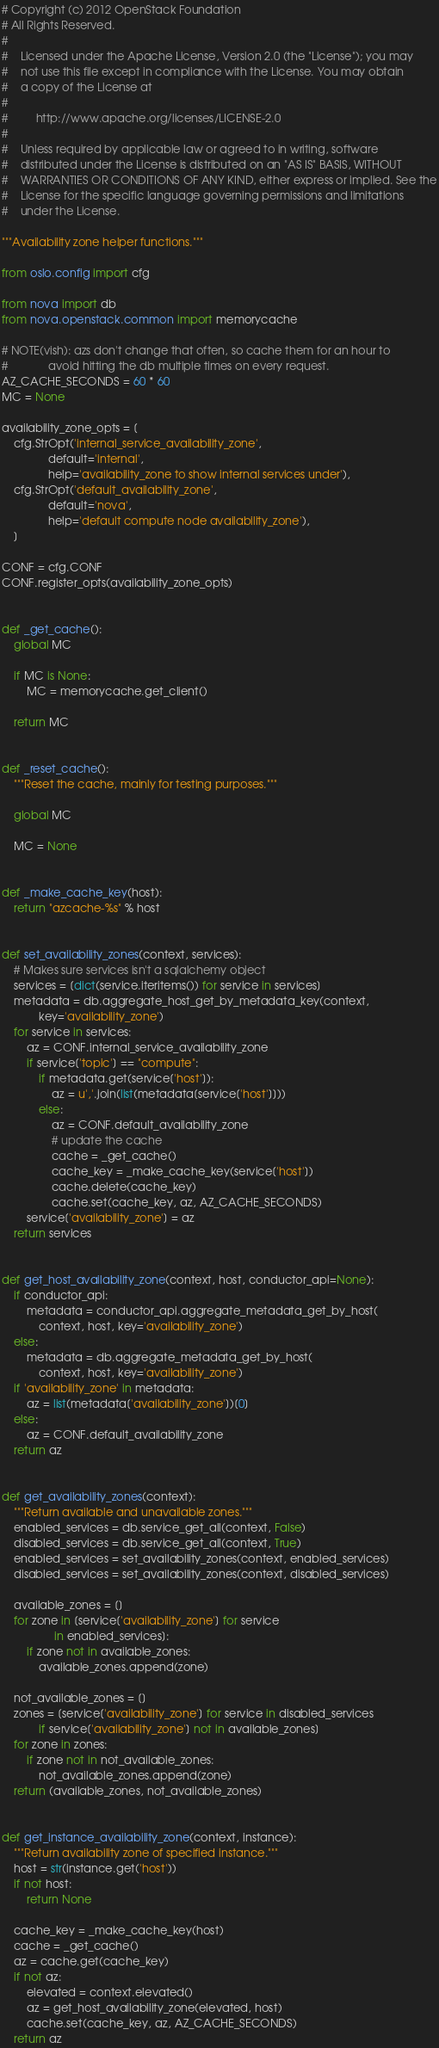Convert code to text. <code><loc_0><loc_0><loc_500><loc_500><_Python_># Copyright (c) 2012 OpenStack Foundation
# All Rights Reserved.
#
#    Licensed under the Apache License, Version 2.0 (the "License"); you may
#    not use this file except in compliance with the License. You may obtain
#    a copy of the License at
#
#         http://www.apache.org/licenses/LICENSE-2.0
#
#    Unless required by applicable law or agreed to in writing, software
#    distributed under the License is distributed on an "AS IS" BASIS, WITHOUT
#    WARRANTIES OR CONDITIONS OF ANY KIND, either express or implied. See the
#    License for the specific language governing permissions and limitations
#    under the License.

"""Availability zone helper functions."""

from oslo.config import cfg

from nova import db
from nova.openstack.common import memorycache

# NOTE(vish): azs don't change that often, so cache them for an hour to
#             avoid hitting the db multiple times on every request.
AZ_CACHE_SECONDS = 60 * 60
MC = None

availability_zone_opts = [
    cfg.StrOpt('internal_service_availability_zone',
               default='internal',
               help='availability_zone to show internal services under'),
    cfg.StrOpt('default_availability_zone',
               default='nova',
               help='default compute node availability_zone'),
    ]

CONF = cfg.CONF
CONF.register_opts(availability_zone_opts)


def _get_cache():
    global MC

    if MC is None:
        MC = memorycache.get_client()

    return MC


def _reset_cache():
    """Reset the cache, mainly for testing purposes."""

    global MC

    MC = None


def _make_cache_key(host):
    return "azcache-%s" % host


def set_availability_zones(context, services):
    # Makes sure services isn't a sqlalchemy object
    services = [dict(service.iteritems()) for service in services]
    metadata = db.aggregate_host_get_by_metadata_key(context,
            key='availability_zone')
    for service in services:
        az = CONF.internal_service_availability_zone
        if service['topic'] == "compute":
            if metadata.get(service['host']):
                az = u','.join(list(metadata[service['host']]))
            else:
                az = CONF.default_availability_zone
                # update the cache
                cache = _get_cache()
                cache_key = _make_cache_key(service['host'])
                cache.delete(cache_key)
                cache.set(cache_key, az, AZ_CACHE_SECONDS)
        service['availability_zone'] = az
    return services


def get_host_availability_zone(context, host, conductor_api=None):
    if conductor_api:
        metadata = conductor_api.aggregate_metadata_get_by_host(
            context, host, key='availability_zone')
    else:
        metadata = db.aggregate_metadata_get_by_host(
            context, host, key='availability_zone')
    if 'availability_zone' in metadata:
        az = list(metadata['availability_zone'])[0]
    else:
        az = CONF.default_availability_zone
    return az


def get_availability_zones(context):
    """Return available and unavailable zones."""
    enabled_services = db.service_get_all(context, False)
    disabled_services = db.service_get_all(context, True)
    enabled_services = set_availability_zones(context, enabled_services)
    disabled_services = set_availability_zones(context, disabled_services)

    available_zones = []
    for zone in [service['availability_zone'] for service
                 in enabled_services]:
        if zone not in available_zones:
            available_zones.append(zone)

    not_available_zones = []
    zones = [service['availability_zone'] for service in disabled_services
            if service['availability_zone'] not in available_zones]
    for zone in zones:
        if zone not in not_available_zones:
            not_available_zones.append(zone)
    return (available_zones, not_available_zones)


def get_instance_availability_zone(context, instance):
    """Return availability zone of specified instance."""
    host = str(instance.get('host'))
    if not host:
        return None

    cache_key = _make_cache_key(host)
    cache = _get_cache()
    az = cache.get(cache_key)
    if not az:
        elevated = context.elevated()
        az = get_host_availability_zone(elevated, host)
        cache.set(cache_key, az, AZ_CACHE_SECONDS)
    return az
</code> 